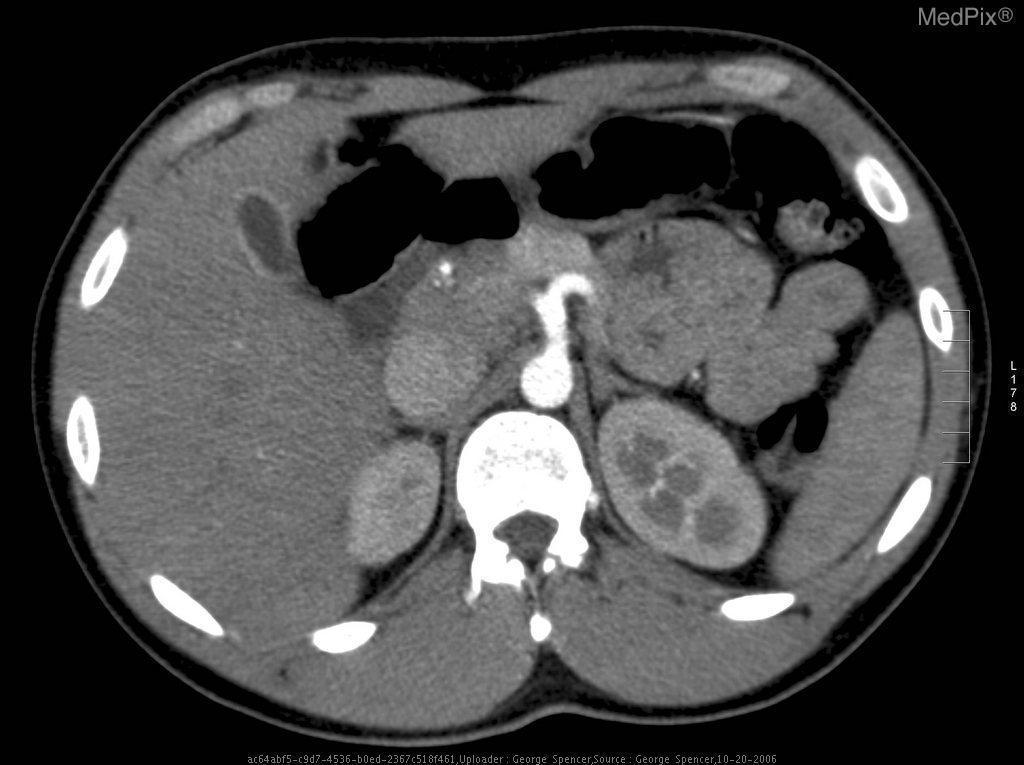Is the liver normal?
Concise answer only. Yes. Is there wall enhancement of the gb?
Answer briefly. Yes. Is the gallbladder wall enhanced by contrast?
Give a very brief answer. Yes. Does this image show a normal gallbladder?
Answer briefly. Yes. Is the gb normal?
Concise answer only. Yes. Is there gall bladder pathology?
Short answer required. No. Is there pathology of the gallbladder?
Answer briefly. No. 